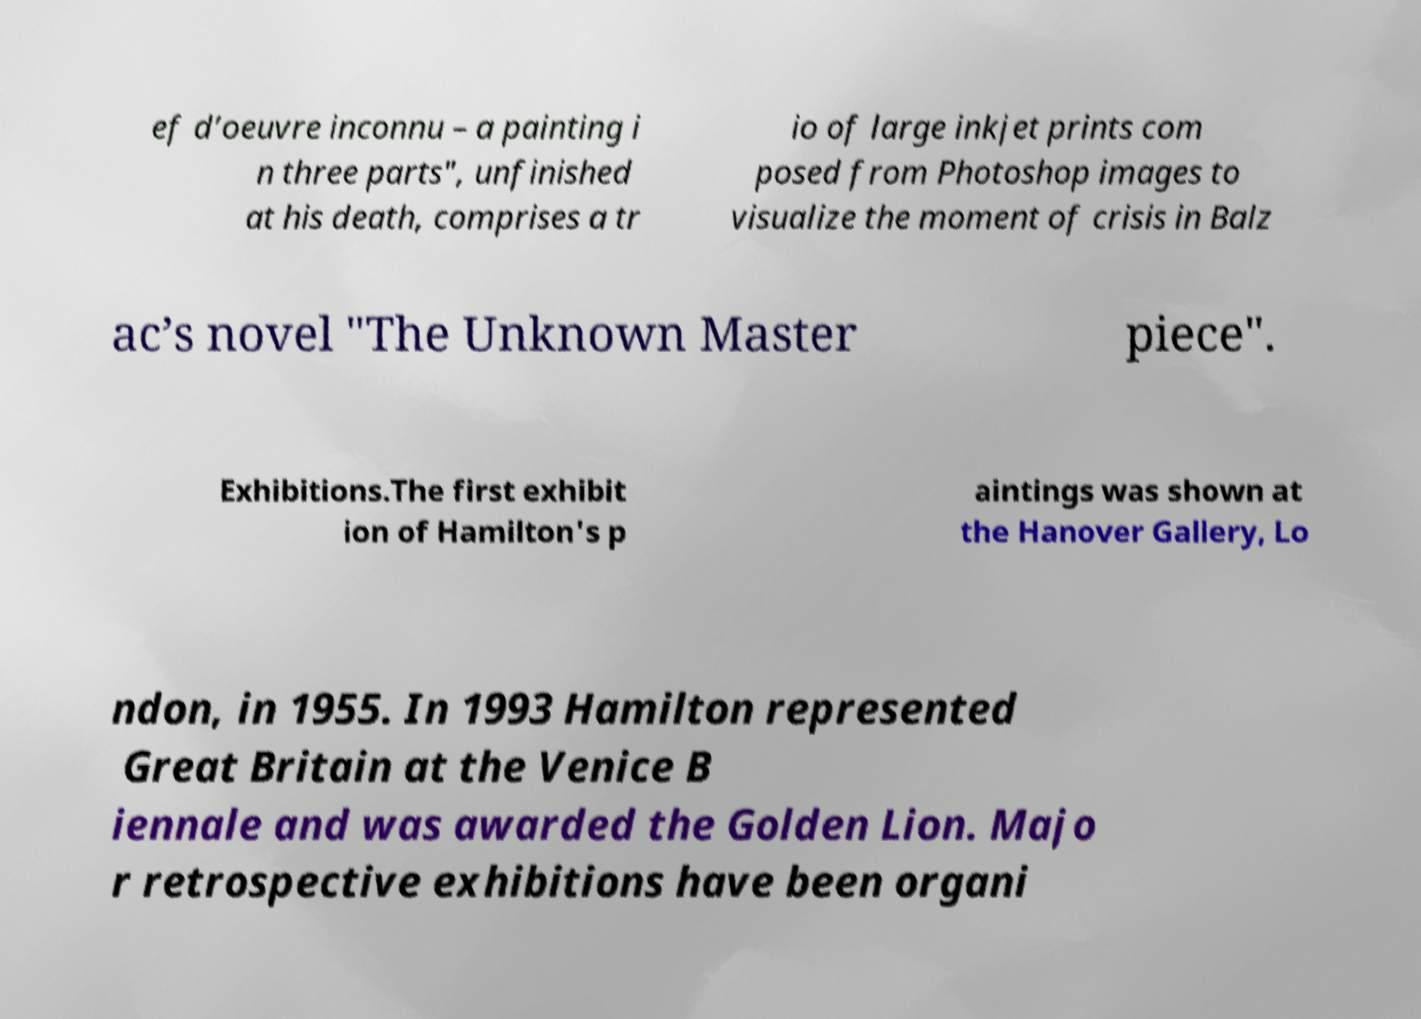There's text embedded in this image that I need extracted. Can you transcribe it verbatim? ef d’oeuvre inconnu – a painting i n three parts", unfinished at his death, comprises a tr io of large inkjet prints com posed from Photoshop images to visualize the moment of crisis in Balz ac’s novel "The Unknown Master piece". Exhibitions.The first exhibit ion of Hamilton's p aintings was shown at the Hanover Gallery, Lo ndon, in 1955. In 1993 Hamilton represented Great Britain at the Venice B iennale and was awarded the Golden Lion. Majo r retrospective exhibitions have been organi 